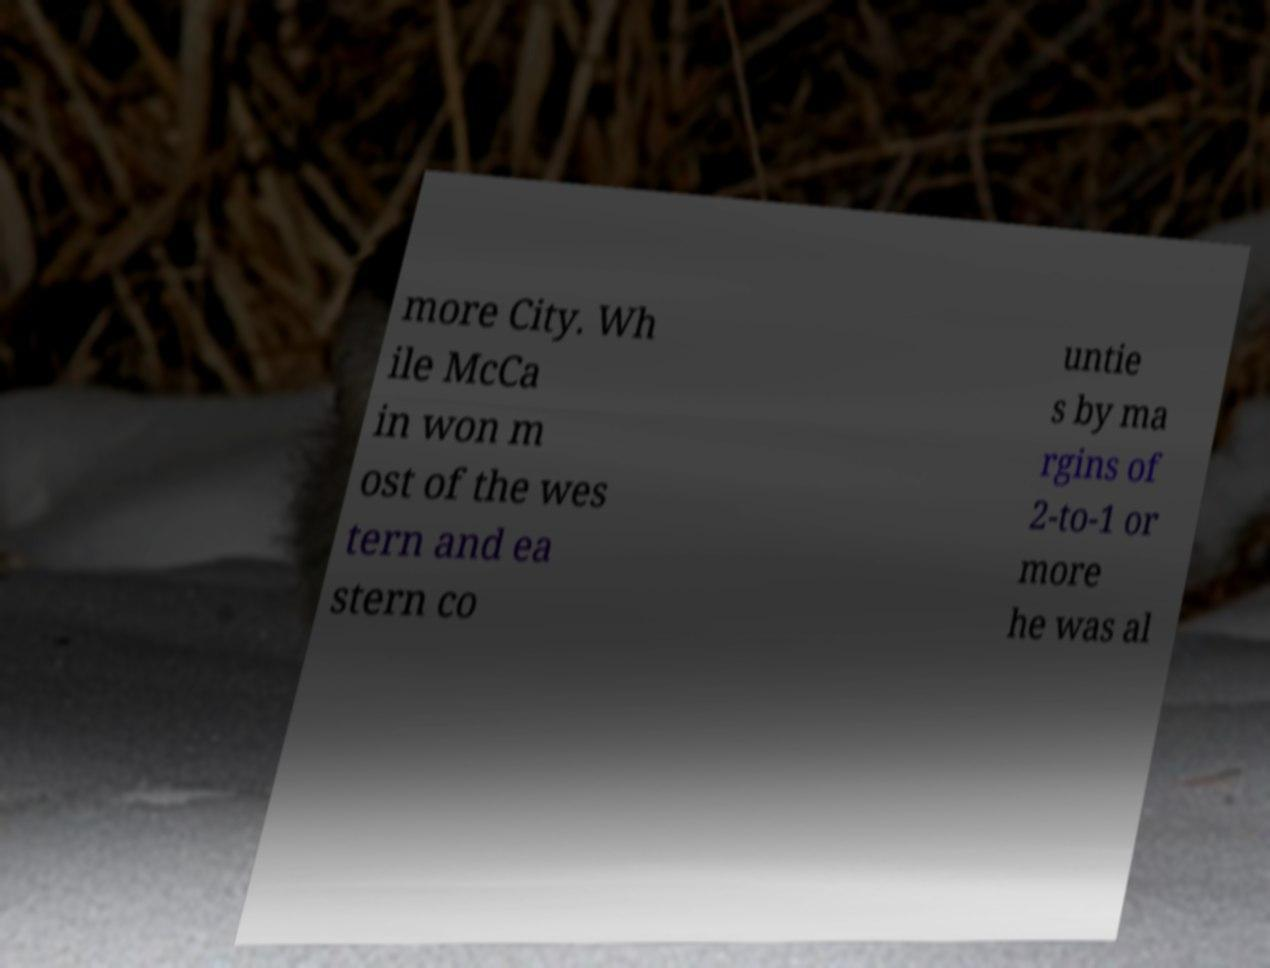Can you read and provide the text displayed in the image?This photo seems to have some interesting text. Can you extract and type it out for me? more City. Wh ile McCa in won m ost of the wes tern and ea stern co untie s by ma rgins of 2-to-1 or more he was al 